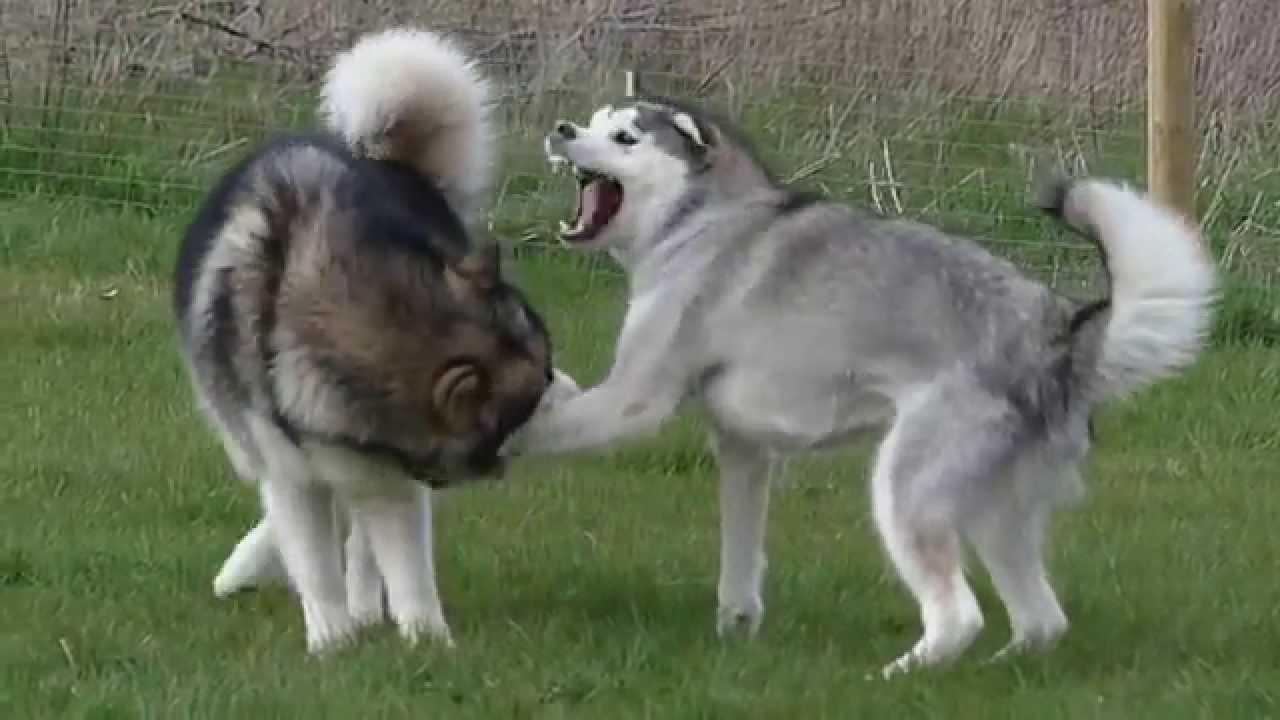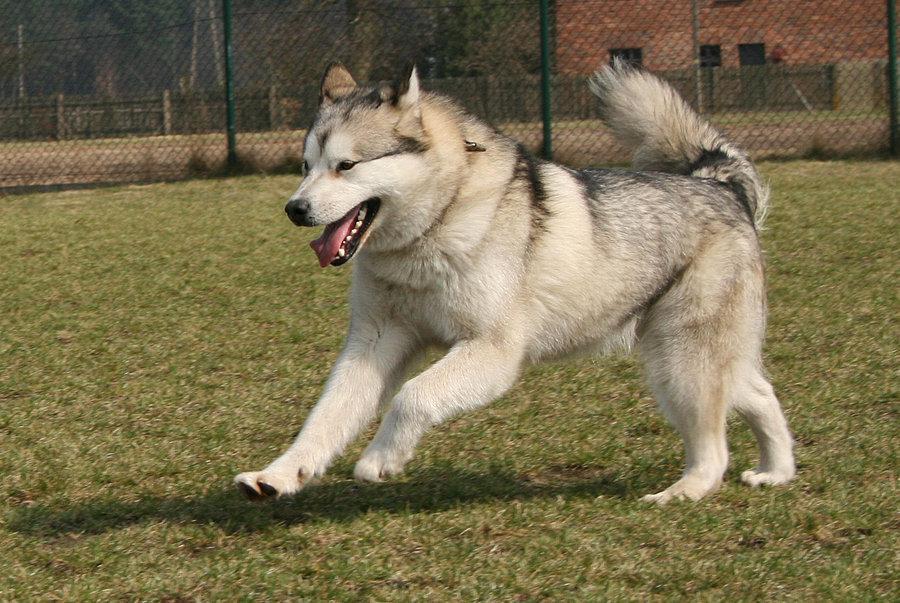The first image is the image on the left, the second image is the image on the right. Examine the images to the left and right. Is the description "Two dogs are standing in the grass in the image on the left." accurate? Answer yes or no. Yes. The first image is the image on the left, the second image is the image on the right. Evaluate the accuracy of this statement regarding the images: "Each image shows two dogs interacting outdoors, and one image contains two gray-and-white husky dogs.". Is it true? Answer yes or no. No. 